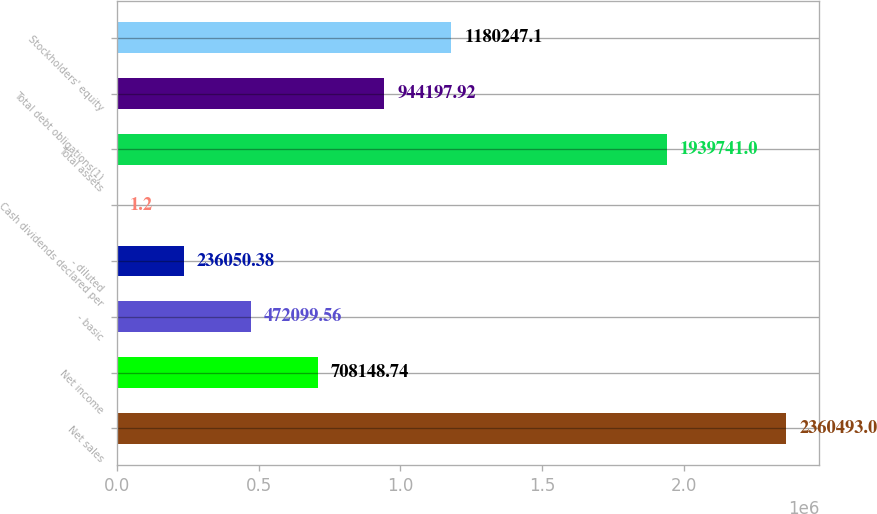<chart> <loc_0><loc_0><loc_500><loc_500><bar_chart><fcel>Net sales<fcel>Net income<fcel>- basic<fcel>- diluted<fcel>Cash dividends declared per<fcel>Total assets<fcel>Total debt obligations(1)<fcel>Stockholders' equity<nl><fcel>2.36049e+06<fcel>708149<fcel>472100<fcel>236050<fcel>1.2<fcel>1.93974e+06<fcel>944198<fcel>1.18025e+06<nl></chart> 